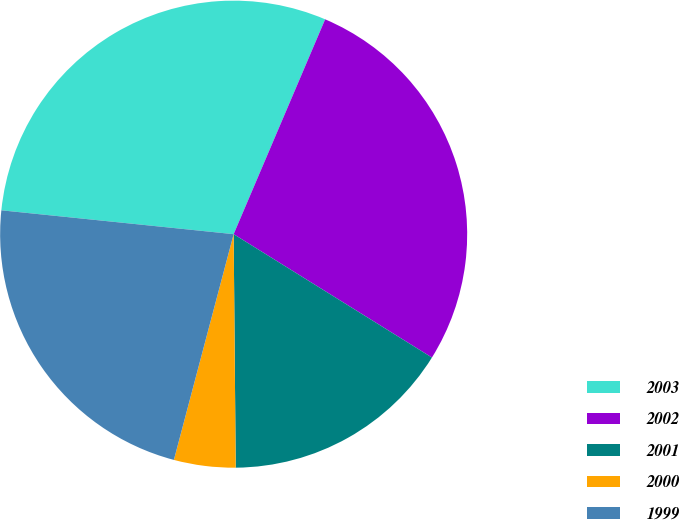Convert chart to OTSL. <chart><loc_0><loc_0><loc_500><loc_500><pie_chart><fcel>2003<fcel>2002<fcel>2001<fcel>2000<fcel>1999<nl><fcel>29.78%<fcel>27.45%<fcel>16.0%<fcel>4.26%<fcel>22.51%<nl></chart> 